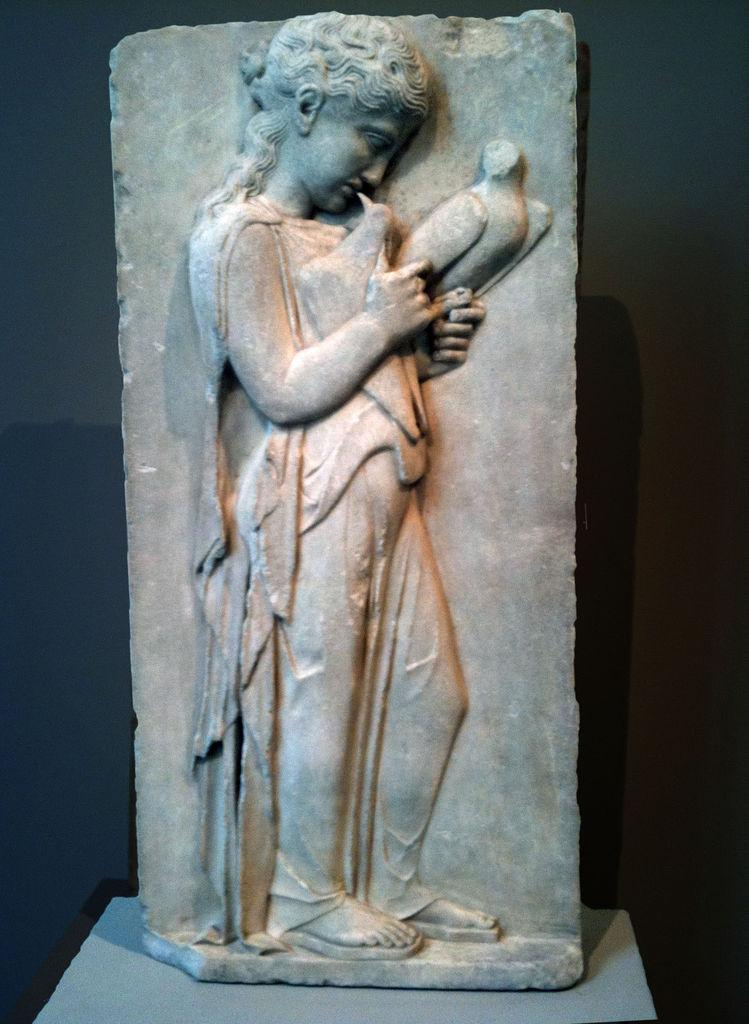What is the main subject of the image? There is a sculpture in the image. What material is the sculpture made of? The sculpture is made of stone. What can be observed about the background of the image? The background of the image is dark. What is the color of the surface on which the sculpture is placed? The sculpture is on a grey color surface. Can you tell me how many soda cans are placed next to the sculpture in the image? There are no soda cans present in the image; it only features a stone sculpture on a grey surface with a dark background. 